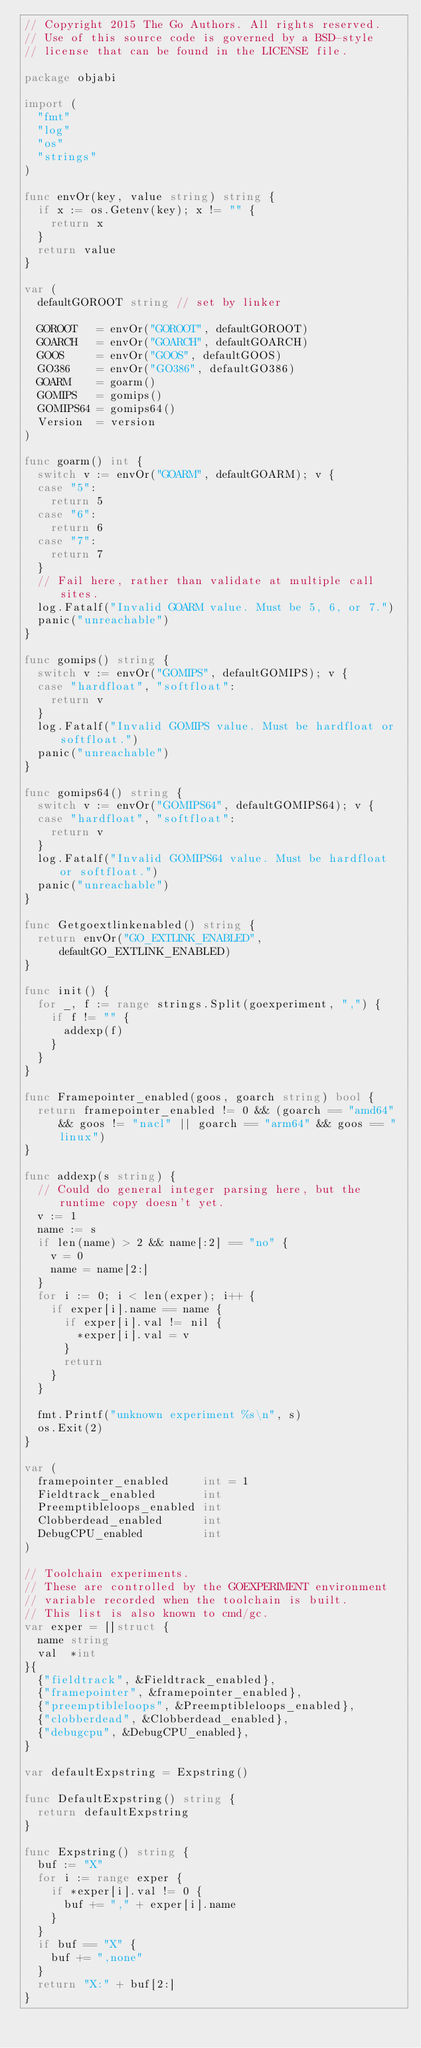<code> <loc_0><loc_0><loc_500><loc_500><_Go_>// Copyright 2015 The Go Authors. All rights reserved.
// Use of this source code is governed by a BSD-style
// license that can be found in the LICENSE file.

package objabi

import (
	"fmt"
	"log"
	"os"
	"strings"
)

func envOr(key, value string) string {
	if x := os.Getenv(key); x != "" {
		return x
	}
	return value
}

var (
	defaultGOROOT string // set by linker

	GOROOT   = envOr("GOROOT", defaultGOROOT)
	GOARCH   = envOr("GOARCH", defaultGOARCH)
	GOOS     = envOr("GOOS", defaultGOOS)
	GO386    = envOr("GO386", defaultGO386)
	GOARM    = goarm()
	GOMIPS   = gomips()
	GOMIPS64 = gomips64()
	Version  = version
)

func goarm() int {
	switch v := envOr("GOARM", defaultGOARM); v {
	case "5":
		return 5
	case "6":
		return 6
	case "7":
		return 7
	}
	// Fail here, rather than validate at multiple call sites.
	log.Fatalf("Invalid GOARM value. Must be 5, 6, or 7.")
	panic("unreachable")
}

func gomips() string {
	switch v := envOr("GOMIPS", defaultGOMIPS); v {
	case "hardfloat", "softfloat":
		return v
	}
	log.Fatalf("Invalid GOMIPS value. Must be hardfloat or softfloat.")
	panic("unreachable")
}

func gomips64() string {
	switch v := envOr("GOMIPS64", defaultGOMIPS64); v {
	case "hardfloat", "softfloat":
		return v
	}
	log.Fatalf("Invalid GOMIPS64 value. Must be hardfloat or softfloat.")
	panic("unreachable")
}

func Getgoextlinkenabled() string {
	return envOr("GO_EXTLINK_ENABLED", defaultGO_EXTLINK_ENABLED)
}

func init() {
	for _, f := range strings.Split(goexperiment, ",") {
		if f != "" {
			addexp(f)
		}
	}
}

func Framepointer_enabled(goos, goarch string) bool {
	return framepointer_enabled != 0 && (goarch == "amd64" && goos != "nacl" || goarch == "arm64" && goos == "linux")
}

func addexp(s string) {
	// Could do general integer parsing here, but the runtime copy doesn't yet.
	v := 1
	name := s
	if len(name) > 2 && name[:2] == "no" {
		v = 0
		name = name[2:]
	}
	for i := 0; i < len(exper); i++ {
		if exper[i].name == name {
			if exper[i].val != nil {
				*exper[i].val = v
			}
			return
		}
	}

	fmt.Printf("unknown experiment %s\n", s)
	os.Exit(2)
}

var (
	framepointer_enabled     int = 1
	Fieldtrack_enabled       int
	Preemptibleloops_enabled int
	Clobberdead_enabled      int
	DebugCPU_enabled         int
)

// Toolchain experiments.
// These are controlled by the GOEXPERIMENT environment
// variable recorded when the toolchain is built.
// This list is also known to cmd/gc.
var exper = []struct {
	name string
	val  *int
}{
	{"fieldtrack", &Fieldtrack_enabled},
	{"framepointer", &framepointer_enabled},
	{"preemptibleloops", &Preemptibleloops_enabled},
	{"clobberdead", &Clobberdead_enabled},
	{"debugcpu", &DebugCPU_enabled},
}

var defaultExpstring = Expstring()

func DefaultExpstring() string {
	return defaultExpstring
}

func Expstring() string {
	buf := "X"
	for i := range exper {
		if *exper[i].val != 0 {
			buf += "," + exper[i].name
		}
	}
	if buf == "X" {
		buf += ",none"
	}
	return "X:" + buf[2:]
}
</code> 